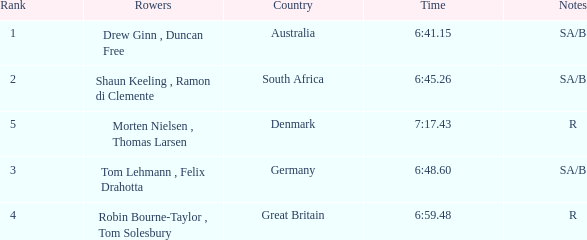What was the time for the rowers representing great britain? 6:59.48. 